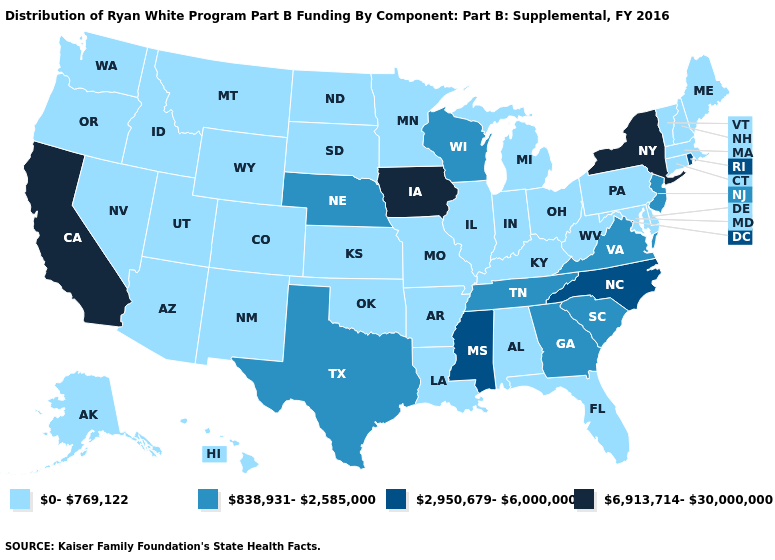Name the states that have a value in the range 838,931-2,585,000?
Be succinct. Georgia, Nebraska, New Jersey, South Carolina, Tennessee, Texas, Virginia, Wisconsin. Does Wyoming have a lower value than Montana?
Short answer required. No. Among the states that border South Dakota , does Wyoming have the lowest value?
Keep it brief. Yes. Name the states that have a value in the range 838,931-2,585,000?
Give a very brief answer. Georgia, Nebraska, New Jersey, South Carolina, Tennessee, Texas, Virginia, Wisconsin. Does the map have missing data?
Keep it brief. No. What is the value of Washington?
Keep it brief. 0-769,122. What is the highest value in states that border Missouri?
Write a very short answer. 6,913,714-30,000,000. What is the lowest value in the USA?
Be succinct. 0-769,122. Does New York have the highest value in the Northeast?
Quick response, please. Yes. What is the lowest value in states that border Pennsylvania?
Keep it brief. 0-769,122. Among the states that border Wisconsin , which have the lowest value?
Write a very short answer. Illinois, Michigan, Minnesota. Does the map have missing data?
Short answer required. No. What is the lowest value in the USA?
Short answer required. 0-769,122. Name the states that have a value in the range 2,950,679-6,000,000?
Give a very brief answer. Mississippi, North Carolina, Rhode Island. Does Missouri have the lowest value in the USA?
Be succinct. Yes. 